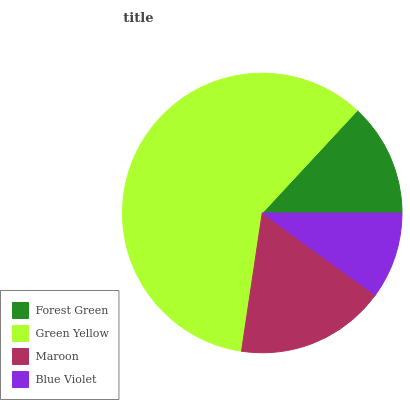Is Blue Violet the minimum?
Answer yes or no. Yes. Is Green Yellow the maximum?
Answer yes or no. Yes. Is Maroon the minimum?
Answer yes or no. No. Is Maroon the maximum?
Answer yes or no. No. Is Green Yellow greater than Maroon?
Answer yes or no. Yes. Is Maroon less than Green Yellow?
Answer yes or no. Yes. Is Maroon greater than Green Yellow?
Answer yes or no. No. Is Green Yellow less than Maroon?
Answer yes or no. No. Is Maroon the high median?
Answer yes or no. Yes. Is Forest Green the low median?
Answer yes or no. Yes. Is Green Yellow the high median?
Answer yes or no. No. Is Green Yellow the low median?
Answer yes or no. No. 